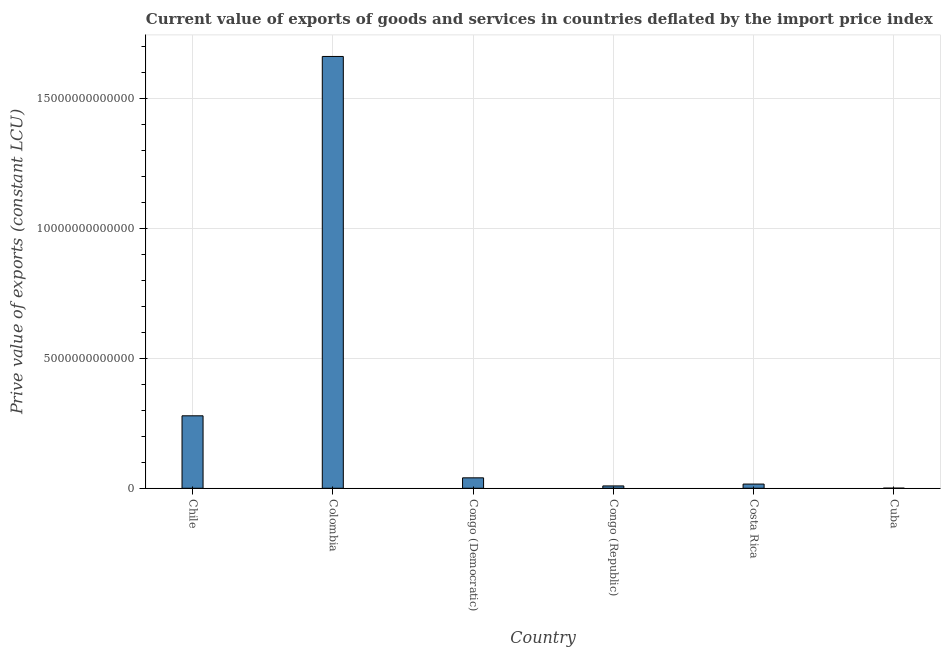Does the graph contain any zero values?
Provide a short and direct response. No. What is the title of the graph?
Ensure brevity in your answer.  Current value of exports of goods and services in countries deflated by the import price index. What is the label or title of the X-axis?
Provide a succinct answer. Country. What is the label or title of the Y-axis?
Your answer should be very brief. Prive value of exports (constant LCU). What is the price value of exports in Costa Rica?
Ensure brevity in your answer.  1.62e+11. Across all countries, what is the maximum price value of exports?
Your answer should be very brief. 1.66e+13. Across all countries, what is the minimum price value of exports?
Offer a terse response. 5.36e+09. In which country was the price value of exports maximum?
Give a very brief answer. Colombia. In which country was the price value of exports minimum?
Keep it short and to the point. Cuba. What is the sum of the price value of exports?
Provide a short and direct response. 2.01e+13. What is the difference between the price value of exports in Chile and Congo (Republic)?
Your answer should be compact. 2.70e+12. What is the average price value of exports per country?
Your answer should be compact. 3.35e+12. What is the median price value of exports?
Offer a terse response. 2.82e+11. What is the ratio of the price value of exports in Congo (Democratic) to that in Congo (Republic)?
Your response must be concise. 4.43. What is the difference between the highest and the second highest price value of exports?
Provide a short and direct response. 1.38e+13. Is the sum of the price value of exports in Colombia and Congo (Democratic) greater than the maximum price value of exports across all countries?
Provide a succinct answer. Yes. What is the difference between the highest and the lowest price value of exports?
Provide a succinct answer. 1.66e+13. Are all the bars in the graph horizontal?
Give a very brief answer. No. How many countries are there in the graph?
Your answer should be compact. 6. What is the difference between two consecutive major ticks on the Y-axis?
Give a very brief answer. 5.00e+12. What is the Prive value of exports (constant LCU) of Chile?
Provide a succinct answer. 2.79e+12. What is the Prive value of exports (constant LCU) of Colombia?
Make the answer very short. 1.66e+13. What is the Prive value of exports (constant LCU) of Congo (Democratic)?
Give a very brief answer. 4.02e+11. What is the Prive value of exports (constant LCU) in Congo (Republic)?
Your answer should be compact. 9.08e+1. What is the Prive value of exports (constant LCU) of Costa Rica?
Provide a succinct answer. 1.62e+11. What is the Prive value of exports (constant LCU) in Cuba?
Ensure brevity in your answer.  5.36e+09. What is the difference between the Prive value of exports (constant LCU) in Chile and Colombia?
Your response must be concise. -1.38e+13. What is the difference between the Prive value of exports (constant LCU) in Chile and Congo (Democratic)?
Your answer should be very brief. 2.39e+12. What is the difference between the Prive value of exports (constant LCU) in Chile and Congo (Republic)?
Keep it short and to the point. 2.70e+12. What is the difference between the Prive value of exports (constant LCU) in Chile and Costa Rica?
Provide a short and direct response. 2.63e+12. What is the difference between the Prive value of exports (constant LCU) in Chile and Cuba?
Give a very brief answer. 2.79e+12. What is the difference between the Prive value of exports (constant LCU) in Colombia and Congo (Democratic)?
Ensure brevity in your answer.  1.62e+13. What is the difference between the Prive value of exports (constant LCU) in Colombia and Congo (Republic)?
Keep it short and to the point. 1.65e+13. What is the difference between the Prive value of exports (constant LCU) in Colombia and Costa Rica?
Give a very brief answer. 1.65e+13. What is the difference between the Prive value of exports (constant LCU) in Colombia and Cuba?
Your answer should be compact. 1.66e+13. What is the difference between the Prive value of exports (constant LCU) in Congo (Democratic) and Congo (Republic)?
Make the answer very short. 3.11e+11. What is the difference between the Prive value of exports (constant LCU) in Congo (Democratic) and Costa Rica?
Ensure brevity in your answer.  2.40e+11. What is the difference between the Prive value of exports (constant LCU) in Congo (Democratic) and Cuba?
Keep it short and to the point. 3.97e+11. What is the difference between the Prive value of exports (constant LCU) in Congo (Republic) and Costa Rica?
Provide a succinct answer. -7.10e+1. What is the difference between the Prive value of exports (constant LCU) in Congo (Republic) and Cuba?
Provide a succinct answer. 8.55e+1. What is the difference between the Prive value of exports (constant LCU) in Costa Rica and Cuba?
Make the answer very short. 1.57e+11. What is the ratio of the Prive value of exports (constant LCU) in Chile to that in Colombia?
Offer a terse response. 0.17. What is the ratio of the Prive value of exports (constant LCU) in Chile to that in Congo (Democratic)?
Your response must be concise. 6.94. What is the ratio of the Prive value of exports (constant LCU) in Chile to that in Congo (Republic)?
Ensure brevity in your answer.  30.73. What is the ratio of the Prive value of exports (constant LCU) in Chile to that in Costa Rica?
Provide a succinct answer. 17.24. What is the ratio of the Prive value of exports (constant LCU) in Chile to that in Cuba?
Make the answer very short. 520.54. What is the ratio of the Prive value of exports (constant LCU) in Colombia to that in Congo (Democratic)?
Make the answer very short. 41.35. What is the ratio of the Prive value of exports (constant LCU) in Colombia to that in Congo (Republic)?
Provide a succinct answer. 183.07. What is the ratio of the Prive value of exports (constant LCU) in Colombia to that in Costa Rica?
Ensure brevity in your answer.  102.73. What is the ratio of the Prive value of exports (constant LCU) in Colombia to that in Cuba?
Your answer should be compact. 3101.08. What is the ratio of the Prive value of exports (constant LCU) in Congo (Democratic) to that in Congo (Republic)?
Make the answer very short. 4.43. What is the ratio of the Prive value of exports (constant LCU) in Congo (Democratic) to that in Costa Rica?
Your answer should be very brief. 2.48. What is the ratio of the Prive value of exports (constant LCU) in Congo (Democratic) to that in Cuba?
Give a very brief answer. 75. What is the ratio of the Prive value of exports (constant LCU) in Congo (Republic) to that in Costa Rica?
Give a very brief answer. 0.56. What is the ratio of the Prive value of exports (constant LCU) in Congo (Republic) to that in Cuba?
Make the answer very short. 16.94. What is the ratio of the Prive value of exports (constant LCU) in Costa Rica to that in Cuba?
Keep it short and to the point. 30.19. 